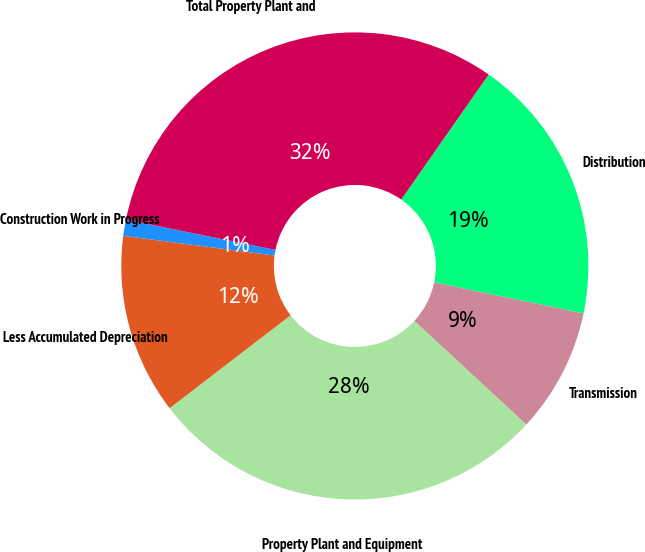Convert chart to OTSL. <chart><loc_0><loc_0><loc_500><loc_500><pie_chart><fcel>Distribution<fcel>Transmission<fcel>Property Plant and Equipment<fcel>Less Accumulated Depreciation<fcel>Construction Work in Progress<fcel>Total Property Plant and<nl><fcel>18.55%<fcel>8.63%<fcel>27.69%<fcel>12.48%<fcel>1.12%<fcel>31.53%<nl></chart> 